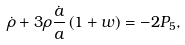<formula> <loc_0><loc_0><loc_500><loc_500>\dot { \rho } + 3 \rho \frac { \dot { a } } { a } \left ( { 1 + w } \right ) = - 2 P _ { 5 } ,</formula> 